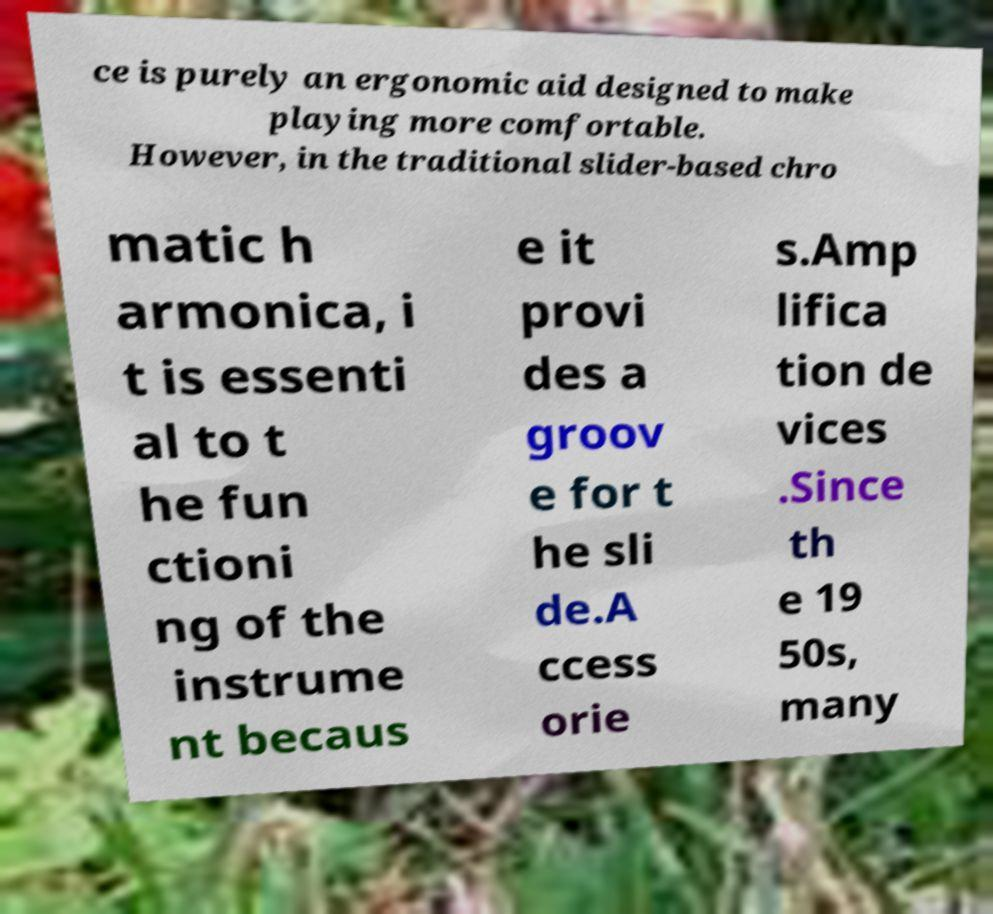Can you read and provide the text displayed in the image?This photo seems to have some interesting text. Can you extract and type it out for me? ce is purely an ergonomic aid designed to make playing more comfortable. However, in the traditional slider-based chro matic h armonica, i t is essenti al to t he fun ctioni ng of the instrume nt becaus e it provi des a groov e for t he sli de.A ccess orie s.Amp lifica tion de vices .Since th e 19 50s, many 